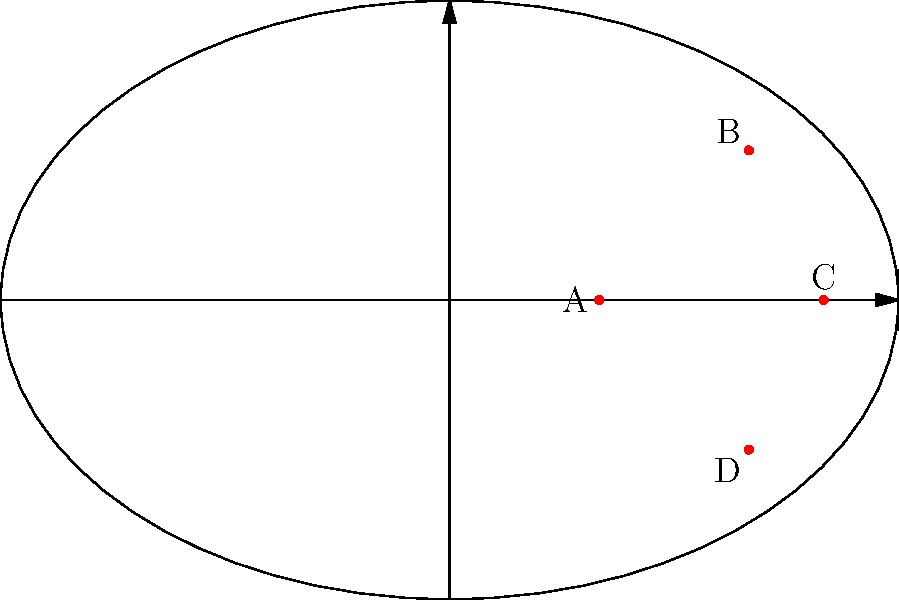Given the ice rink diagram showing four player positions (A, B, C, and D), which position would likely result in the highest shot accuracy for a right-handed shooter like Alex Ovechkin? To determine the position with the highest shot accuracy, we need to consider several factors:

1. Distance from the goal: Closer shots are generally more accurate.
2. Angle to the goal: A more direct angle provides a larger target area.
3. Handedness of the shooter: Right-handed shooters typically have an advantage when shooting from the left side of the ice.

Let's analyze each position:

A: Furthest from the goal, but with a good angle. Not ideal for a right-handed shooter.
B: Good distance, but a sharp angle and on the right side of the ice.
C: Closest to the goal with a direct angle, but slightly to the right of center.
D: Good distance, better angle than B, and on the left side of the ice (favoring right-handed shooters).

Position C is the closest to the goal with the most direct angle, which generally results in the highest shot accuracy. While it's slightly to the right of center, the proximity to the goal outweighs this minor disadvantage for a skilled shooter like Ovechkin.

Position D would be a close second choice, as it favors Ovechkin's right-handed shot, but it's further from the goal than C.
Answer: C 